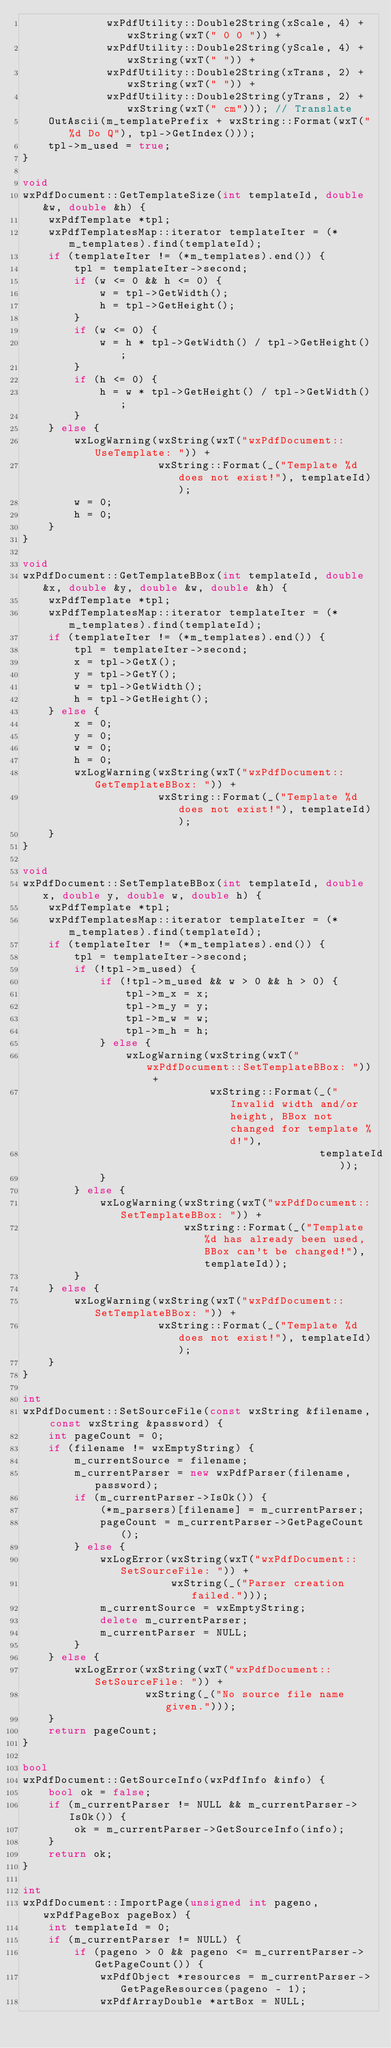Convert code to text. <code><loc_0><loc_0><loc_500><loc_500><_C++_>             wxPdfUtility::Double2String(xScale, 4) + wxString(wxT(" 0 0 ")) +
             wxPdfUtility::Double2String(yScale, 4) + wxString(wxT(" ")) +
             wxPdfUtility::Double2String(xTrans, 2) + wxString(wxT(" ")) +
             wxPdfUtility::Double2String(yTrans, 2) + wxString(wxT(" cm"))); // Translate
    OutAscii(m_templatePrefix + wxString::Format(wxT("%d Do Q"), tpl->GetIndex()));
    tpl->m_used = true;
}

void
wxPdfDocument::GetTemplateSize(int templateId, double &w, double &h) {
    wxPdfTemplate *tpl;
    wxPdfTemplatesMap::iterator templateIter = (*m_templates).find(templateId);
    if (templateIter != (*m_templates).end()) {
        tpl = templateIter->second;
        if (w <= 0 && h <= 0) {
            w = tpl->GetWidth();
            h = tpl->GetHeight();
        }
        if (w <= 0) {
            w = h * tpl->GetWidth() / tpl->GetHeight();
        }
        if (h <= 0) {
            h = w * tpl->GetHeight() / tpl->GetWidth();
        }
    } else {
        wxLogWarning(wxString(wxT("wxPdfDocument::UseTemplate: ")) +
                     wxString::Format(_("Template %d does not exist!"), templateId));
        w = 0;
        h = 0;
    }
}

void
wxPdfDocument::GetTemplateBBox(int templateId, double &x, double &y, double &w, double &h) {
    wxPdfTemplate *tpl;
    wxPdfTemplatesMap::iterator templateIter = (*m_templates).find(templateId);
    if (templateIter != (*m_templates).end()) {
        tpl = templateIter->second;
        x = tpl->GetX();
        y = tpl->GetY();
        w = tpl->GetWidth();
        h = tpl->GetHeight();
    } else {
        x = 0;
        y = 0;
        w = 0;
        h = 0;
        wxLogWarning(wxString(wxT("wxPdfDocument::GetTemplateBBox: ")) +
                     wxString::Format(_("Template %d does not exist!"), templateId));
    }
}

void
wxPdfDocument::SetTemplateBBox(int templateId, double x, double y, double w, double h) {
    wxPdfTemplate *tpl;
    wxPdfTemplatesMap::iterator templateIter = (*m_templates).find(templateId);
    if (templateIter != (*m_templates).end()) {
        tpl = templateIter->second;
        if (!tpl->m_used) {
            if (!tpl->m_used && w > 0 && h > 0) {
                tpl->m_x = x;
                tpl->m_y = y;
                tpl->m_w = w;
                tpl->m_h = h;
            } else {
                wxLogWarning(wxString(wxT("wxPdfDocument::SetTemplateBBox: ")) +
                             wxString::Format(_("Invalid width and/or height, BBox not changed for template %d!"),
                                              templateId));
            }
        } else {
            wxLogWarning(wxString(wxT("wxPdfDocument::SetTemplateBBox: ")) +
                         wxString::Format(_("Template %d has already been used, BBox can't be changed!"), templateId));
        }
    } else {
        wxLogWarning(wxString(wxT("wxPdfDocument::SetTemplateBBox: ")) +
                     wxString::Format(_("Template %d does not exist!"), templateId));
    }
}

int
wxPdfDocument::SetSourceFile(const wxString &filename, const wxString &password) {
    int pageCount = 0;
    if (filename != wxEmptyString) {
        m_currentSource = filename;
        m_currentParser = new wxPdfParser(filename, password);
        if (m_currentParser->IsOk()) {
            (*m_parsers)[filename] = m_currentParser;
            pageCount = m_currentParser->GetPageCount();
        } else {
            wxLogError(wxString(wxT("wxPdfDocument::SetSourceFile: ")) +
                       wxString(_("Parser creation failed.")));
            m_currentSource = wxEmptyString;
            delete m_currentParser;
            m_currentParser = NULL;
        }
    } else {
        wxLogError(wxString(wxT("wxPdfDocument::SetSourceFile: ")) +
                   wxString(_("No source file name given.")));
    }
    return pageCount;
}

bool
wxPdfDocument::GetSourceInfo(wxPdfInfo &info) {
    bool ok = false;
    if (m_currentParser != NULL && m_currentParser->IsOk()) {
        ok = m_currentParser->GetSourceInfo(info);
    }
    return ok;
}

int
wxPdfDocument::ImportPage(unsigned int pageno, wxPdfPageBox pageBox) {
    int templateId = 0;
    if (m_currentParser != NULL) {
        if (pageno > 0 && pageno <= m_currentParser->GetPageCount()) {
            wxPdfObject *resources = m_currentParser->GetPageResources(pageno - 1);
            wxPdfArrayDouble *artBox = NULL;</code> 